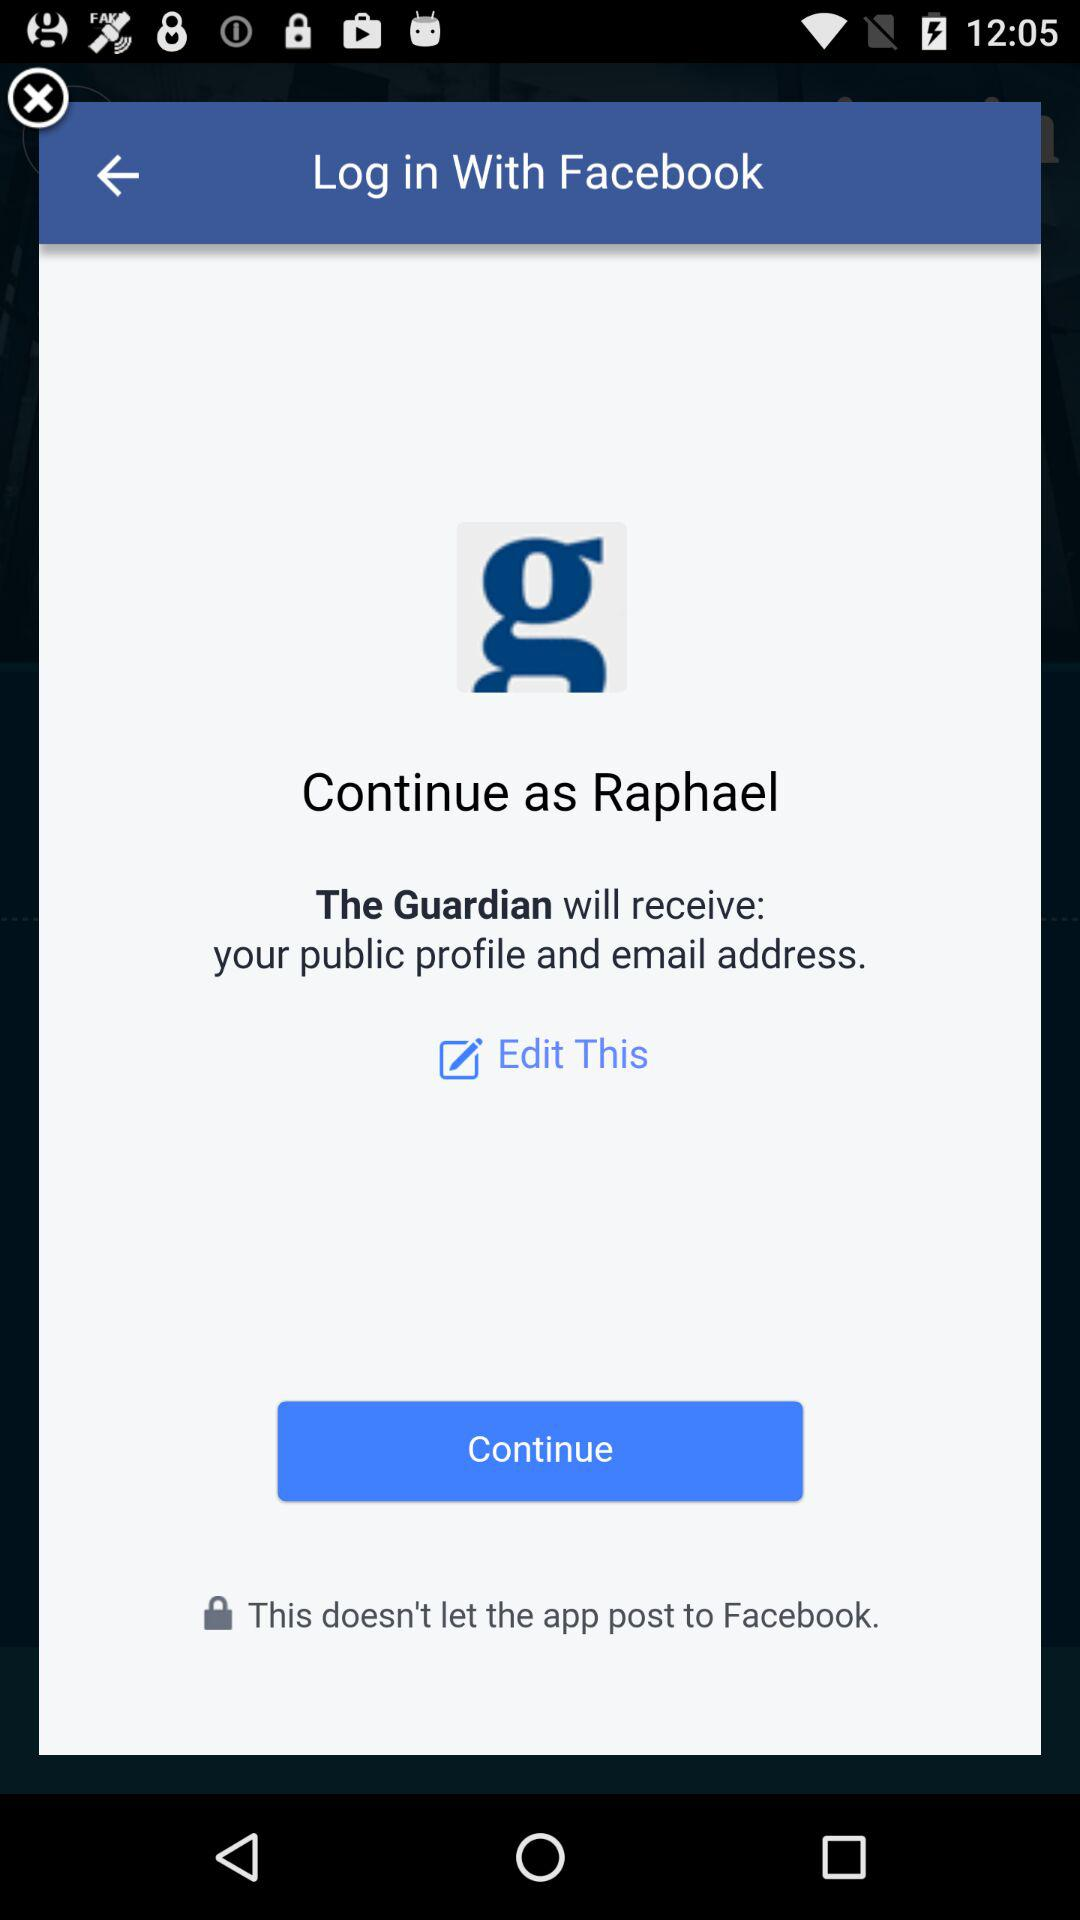What application will receive the public figure and email address? The application is "The Guardian". 